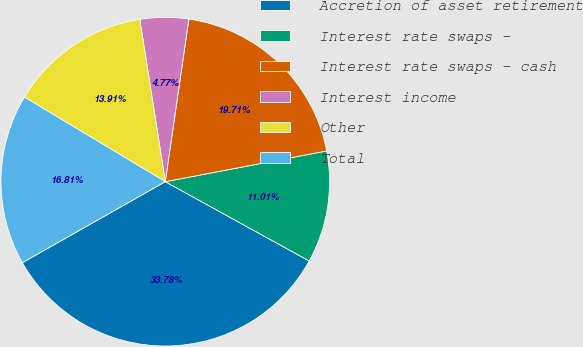Convert chart. <chart><loc_0><loc_0><loc_500><loc_500><pie_chart><fcel>Accretion of asset retirement<fcel>Interest rate swaps -<fcel>Interest rate swaps - cash<fcel>Interest income<fcel>Other<fcel>Total<nl><fcel>33.77%<fcel>11.01%<fcel>19.71%<fcel>4.77%<fcel>13.91%<fcel>16.81%<nl></chart> 